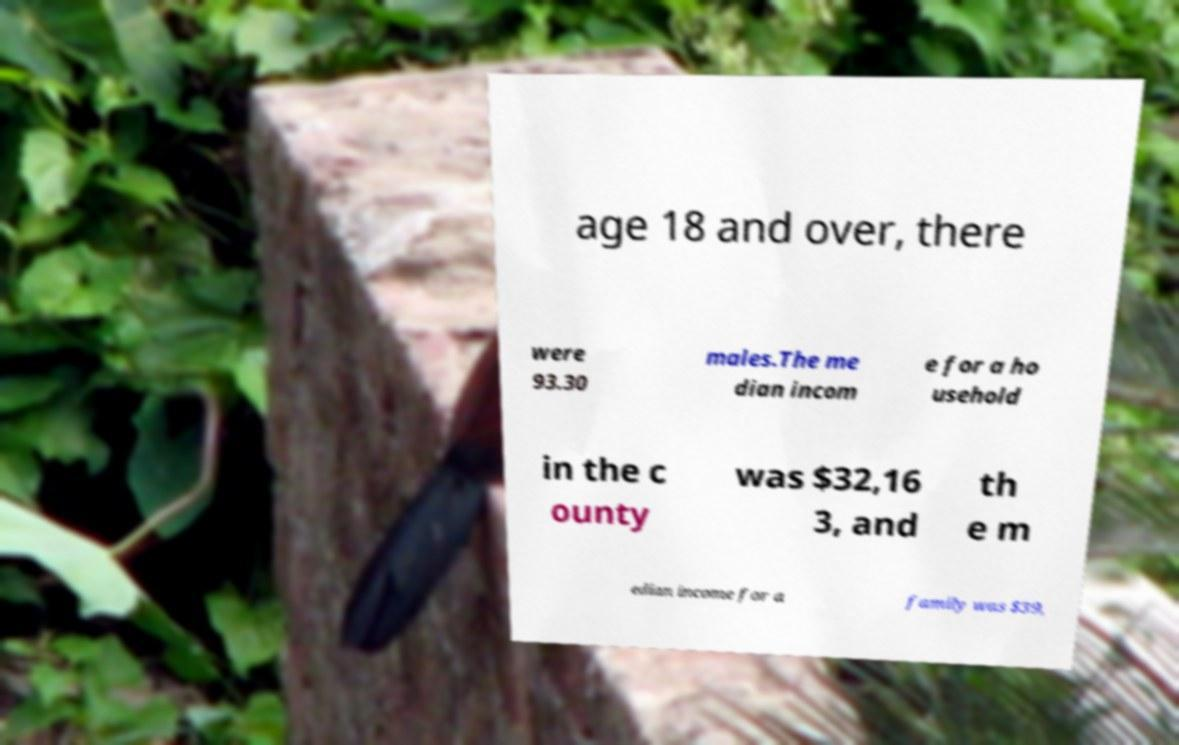Can you read and provide the text displayed in the image?This photo seems to have some interesting text. Can you extract and type it out for me? age 18 and over, there were 93.30 males.The me dian incom e for a ho usehold in the c ounty was $32,16 3, and th e m edian income for a family was $39, 